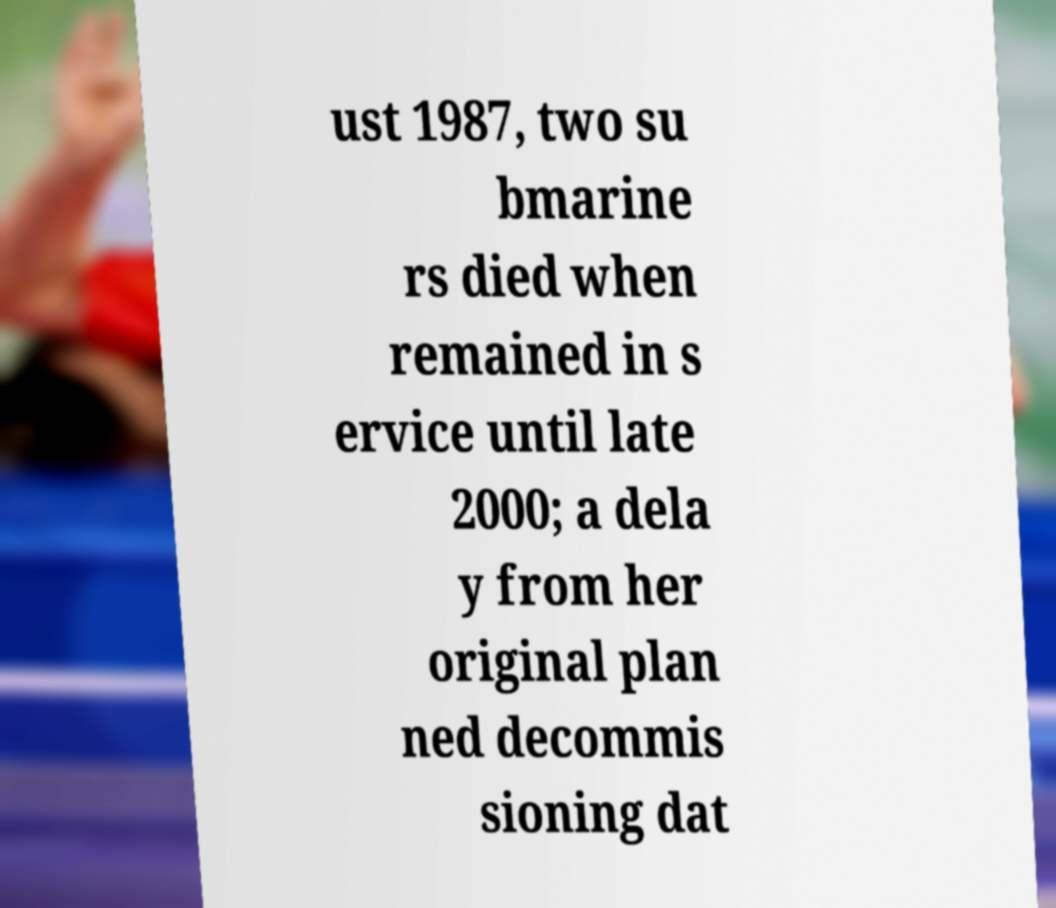Could you assist in decoding the text presented in this image and type it out clearly? ust 1987, two su bmarine rs died when remained in s ervice until late 2000; a dela y from her original plan ned decommis sioning dat 